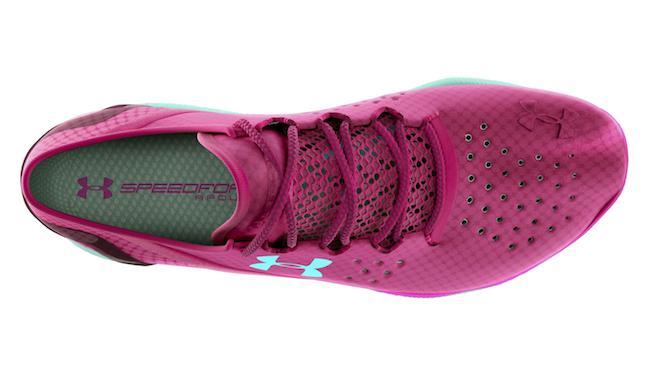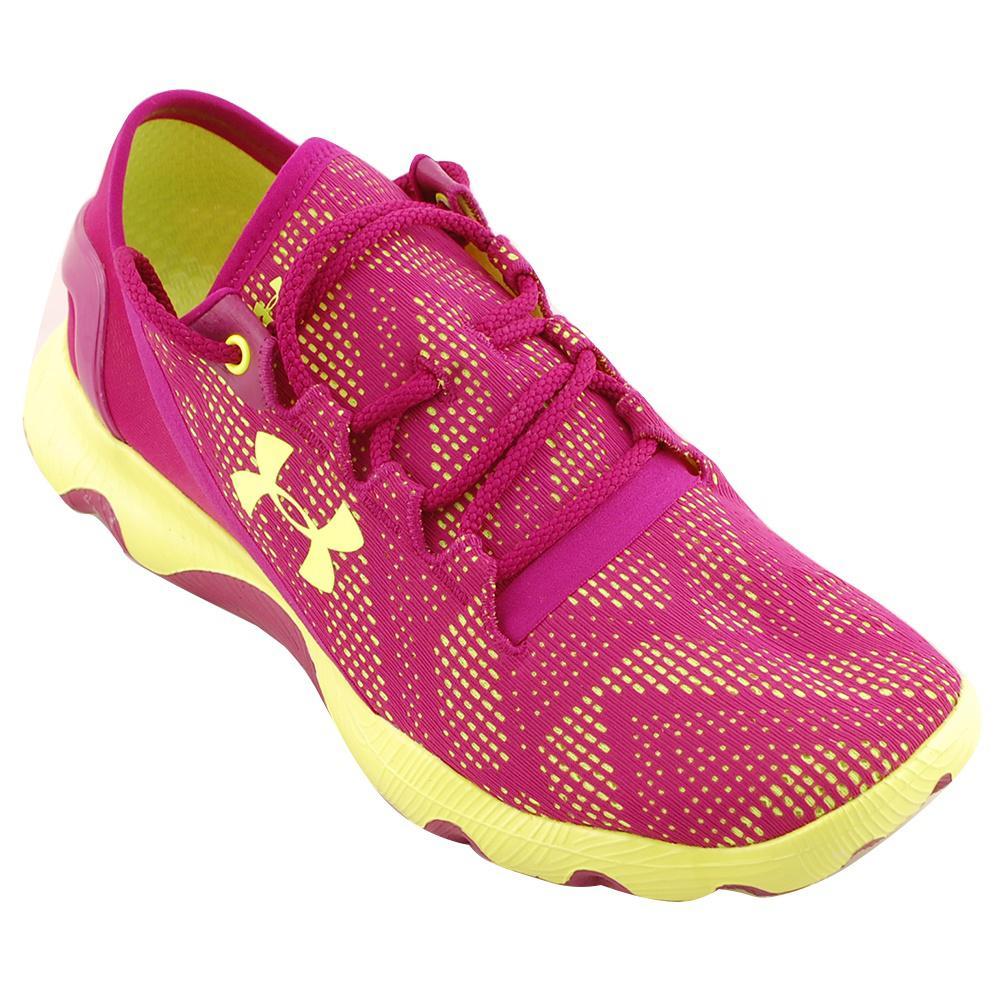The first image is the image on the left, the second image is the image on the right. Considering the images on both sides, is "One of the images contains a pink and yellow shoe." valid? Answer yes or no. Yes. The first image is the image on the left, the second image is the image on the right. Given the left and right images, does the statement "There are three shoes." hold true? Answer yes or no. No. 